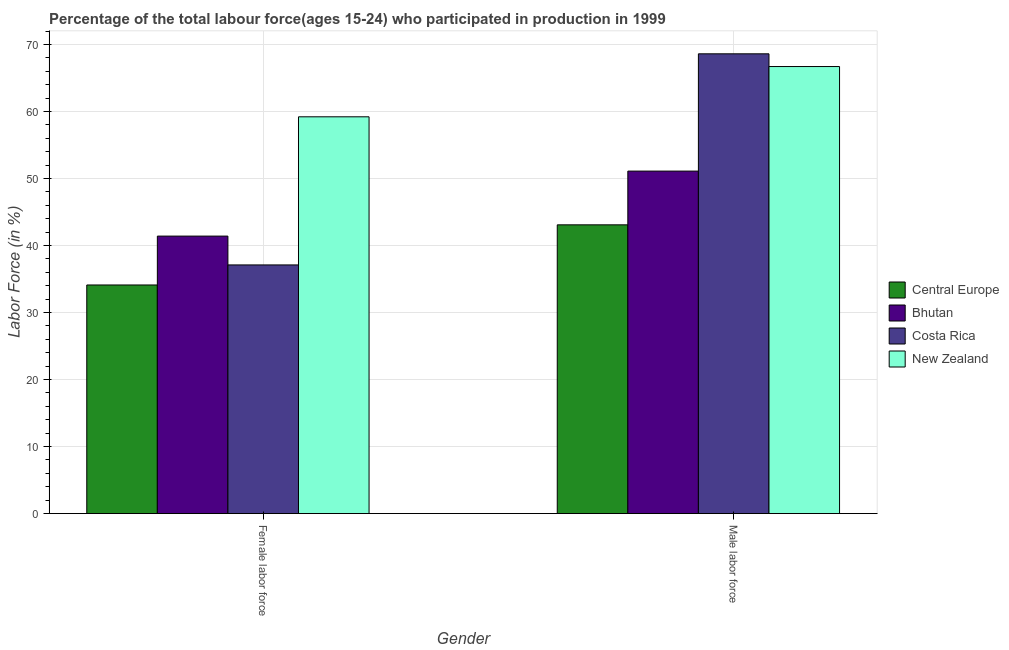How many different coloured bars are there?
Your answer should be very brief. 4. Are the number of bars per tick equal to the number of legend labels?
Your answer should be very brief. Yes. Are the number of bars on each tick of the X-axis equal?
Offer a terse response. Yes. What is the label of the 1st group of bars from the left?
Offer a terse response. Female labor force. What is the percentage of female labor force in Bhutan?
Ensure brevity in your answer.  41.4. Across all countries, what is the maximum percentage of male labour force?
Your answer should be very brief. 68.6. Across all countries, what is the minimum percentage of male labour force?
Keep it short and to the point. 43.08. In which country was the percentage of male labour force maximum?
Your response must be concise. Costa Rica. In which country was the percentage of male labour force minimum?
Make the answer very short. Central Europe. What is the total percentage of male labour force in the graph?
Your answer should be compact. 229.48. What is the difference between the percentage of female labor force in Bhutan and that in Costa Rica?
Your response must be concise. 4.3. What is the difference between the percentage of female labor force in Central Europe and the percentage of male labour force in Bhutan?
Offer a terse response. -16.99. What is the average percentage of male labour force per country?
Keep it short and to the point. 57.37. What is the difference between the percentage of female labor force and percentage of male labour force in Central Europe?
Offer a very short reply. -8.97. What is the ratio of the percentage of male labour force in Bhutan to that in New Zealand?
Keep it short and to the point. 0.77. Is the percentage of female labor force in Costa Rica less than that in Bhutan?
Offer a very short reply. Yes. In how many countries, is the percentage of female labor force greater than the average percentage of female labor force taken over all countries?
Your response must be concise. 1. What does the 3rd bar from the left in Male labor force represents?
Offer a terse response. Costa Rica. What does the 1st bar from the right in Female labor force represents?
Make the answer very short. New Zealand. Are all the bars in the graph horizontal?
Make the answer very short. No. How many countries are there in the graph?
Offer a terse response. 4. Does the graph contain grids?
Your answer should be compact. Yes. Where does the legend appear in the graph?
Provide a succinct answer. Center right. How many legend labels are there?
Your answer should be very brief. 4. How are the legend labels stacked?
Provide a succinct answer. Vertical. What is the title of the graph?
Provide a short and direct response. Percentage of the total labour force(ages 15-24) who participated in production in 1999. Does "Congo (Democratic)" appear as one of the legend labels in the graph?
Offer a terse response. No. What is the Labor Force (in %) of Central Europe in Female labor force?
Ensure brevity in your answer.  34.11. What is the Labor Force (in %) in Bhutan in Female labor force?
Your response must be concise. 41.4. What is the Labor Force (in %) in Costa Rica in Female labor force?
Make the answer very short. 37.1. What is the Labor Force (in %) of New Zealand in Female labor force?
Keep it short and to the point. 59.2. What is the Labor Force (in %) of Central Europe in Male labor force?
Offer a very short reply. 43.08. What is the Labor Force (in %) in Bhutan in Male labor force?
Your response must be concise. 51.1. What is the Labor Force (in %) in Costa Rica in Male labor force?
Offer a very short reply. 68.6. What is the Labor Force (in %) of New Zealand in Male labor force?
Your response must be concise. 66.7. Across all Gender, what is the maximum Labor Force (in %) in Central Europe?
Offer a terse response. 43.08. Across all Gender, what is the maximum Labor Force (in %) of Bhutan?
Keep it short and to the point. 51.1. Across all Gender, what is the maximum Labor Force (in %) of Costa Rica?
Provide a succinct answer. 68.6. Across all Gender, what is the maximum Labor Force (in %) of New Zealand?
Your answer should be very brief. 66.7. Across all Gender, what is the minimum Labor Force (in %) in Central Europe?
Ensure brevity in your answer.  34.11. Across all Gender, what is the minimum Labor Force (in %) of Bhutan?
Keep it short and to the point. 41.4. Across all Gender, what is the minimum Labor Force (in %) in Costa Rica?
Your response must be concise. 37.1. Across all Gender, what is the minimum Labor Force (in %) in New Zealand?
Provide a succinct answer. 59.2. What is the total Labor Force (in %) of Central Europe in the graph?
Your response must be concise. 77.19. What is the total Labor Force (in %) of Bhutan in the graph?
Your answer should be compact. 92.5. What is the total Labor Force (in %) in Costa Rica in the graph?
Offer a terse response. 105.7. What is the total Labor Force (in %) in New Zealand in the graph?
Your response must be concise. 125.9. What is the difference between the Labor Force (in %) of Central Europe in Female labor force and that in Male labor force?
Give a very brief answer. -8.97. What is the difference between the Labor Force (in %) in Bhutan in Female labor force and that in Male labor force?
Offer a very short reply. -9.7. What is the difference between the Labor Force (in %) of Costa Rica in Female labor force and that in Male labor force?
Give a very brief answer. -31.5. What is the difference between the Labor Force (in %) in Central Europe in Female labor force and the Labor Force (in %) in Bhutan in Male labor force?
Your answer should be compact. -16.99. What is the difference between the Labor Force (in %) of Central Europe in Female labor force and the Labor Force (in %) of Costa Rica in Male labor force?
Your answer should be compact. -34.49. What is the difference between the Labor Force (in %) in Central Europe in Female labor force and the Labor Force (in %) in New Zealand in Male labor force?
Keep it short and to the point. -32.59. What is the difference between the Labor Force (in %) in Bhutan in Female labor force and the Labor Force (in %) in Costa Rica in Male labor force?
Offer a terse response. -27.2. What is the difference between the Labor Force (in %) in Bhutan in Female labor force and the Labor Force (in %) in New Zealand in Male labor force?
Provide a succinct answer. -25.3. What is the difference between the Labor Force (in %) in Costa Rica in Female labor force and the Labor Force (in %) in New Zealand in Male labor force?
Give a very brief answer. -29.6. What is the average Labor Force (in %) of Central Europe per Gender?
Keep it short and to the point. 38.6. What is the average Labor Force (in %) in Bhutan per Gender?
Offer a terse response. 46.25. What is the average Labor Force (in %) of Costa Rica per Gender?
Your response must be concise. 52.85. What is the average Labor Force (in %) in New Zealand per Gender?
Make the answer very short. 62.95. What is the difference between the Labor Force (in %) in Central Europe and Labor Force (in %) in Bhutan in Female labor force?
Make the answer very short. -7.29. What is the difference between the Labor Force (in %) in Central Europe and Labor Force (in %) in Costa Rica in Female labor force?
Your answer should be compact. -2.99. What is the difference between the Labor Force (in %) of Central Europe and Labor Force (in %) of New Zealand in Female labor force?
Offer a terse response. -25.09. What is the difference between the Labor Force (in %) of Bhutan and Labor Force (in %) of New Zealand in Female labor force?
Give a very brief answer. -17.8. What is the difference between the Labor Force (in %) in Costa Rica and Labor Force (in %) in New Zealand in Female labor force?
Make the answer very short. -22.1. What is the difference between the Labor Force (in %) in Central Europe and Labor Force (in %) in Bhutan in Male labor force?
Give a very brief answer. -8.02. What is the difference between the Labor Force (in %) in Central Europe and Labor Force (in %) in Costa Rica in Male labor force?
Give a very brief answer. -25.52. What is the difference between the Labor Force (in %) in Central Europe and Labor Force (in %) in New Zealand in Male labor force?
Offer a terse response. -23.62. What is the difference between the Labor Force (in %) of Bhutan and Labor Force (in %) of Costa Rica in Male labor force?
Offer a terse response. -17.5. What is the difference between the Labor Force (in %) in Bhutan and Labor Force (in %) in New Zealand in Male labor force?
Give a very brief answer. -15.6. What is the difference between the Labor Force (in %) of Costa Rica and Labor Force (in %) of New Zealand in Male labor force?
Offer a very short reply. 1.9. What is the ratio of the Labor Force (in %) of Central Europe in Female labor force to that in Male labor force?
Provide a short and direct response. 0.79. What is the ratio of the Labor Force (in %) of Bhutan in Female labor force to that in Male labor force?
Offer a terse response. 0.81. What is the ratio of the Labor Force (in %) in Costa Rica in Female labor force to that in Male labor force?
Keep it short and to the point. 0.54. What is the ratio of the Labor Force (in %) of New Zealand in Female labor force to that in Male labor force?
Give a very brief answer. 0.89. What is the difference between the highest and the second highest Labor Force (in %) of Central Europe?
Provide a succinct answer. 8.97. What is the difference between the highest and the second highest Labor Force (in %) of Bhutan?
Give a very brief answer. 9.7. What is the difference between the highest and the second highest Labor Force (in %) of Costa Rica?
Provide a short and direct response. 31.5. What is the difference between the highest and the second highest Labor Force (in %) of New Zealand?
Ensure brevity in your answer.  7.5. What is the difference between the highest and the lowest Labor Force (in %) in Central Europe?
Offer a very short reply. 8.97. What is the difference between the highest and the lowest Labor Force (in %) of Bhutan?
Give a very brief answer. 9.7. What is the difference between the highest and the lowest Labor Force (in %) in Costa Rica?
Provide a succinct answer. 31.5. 